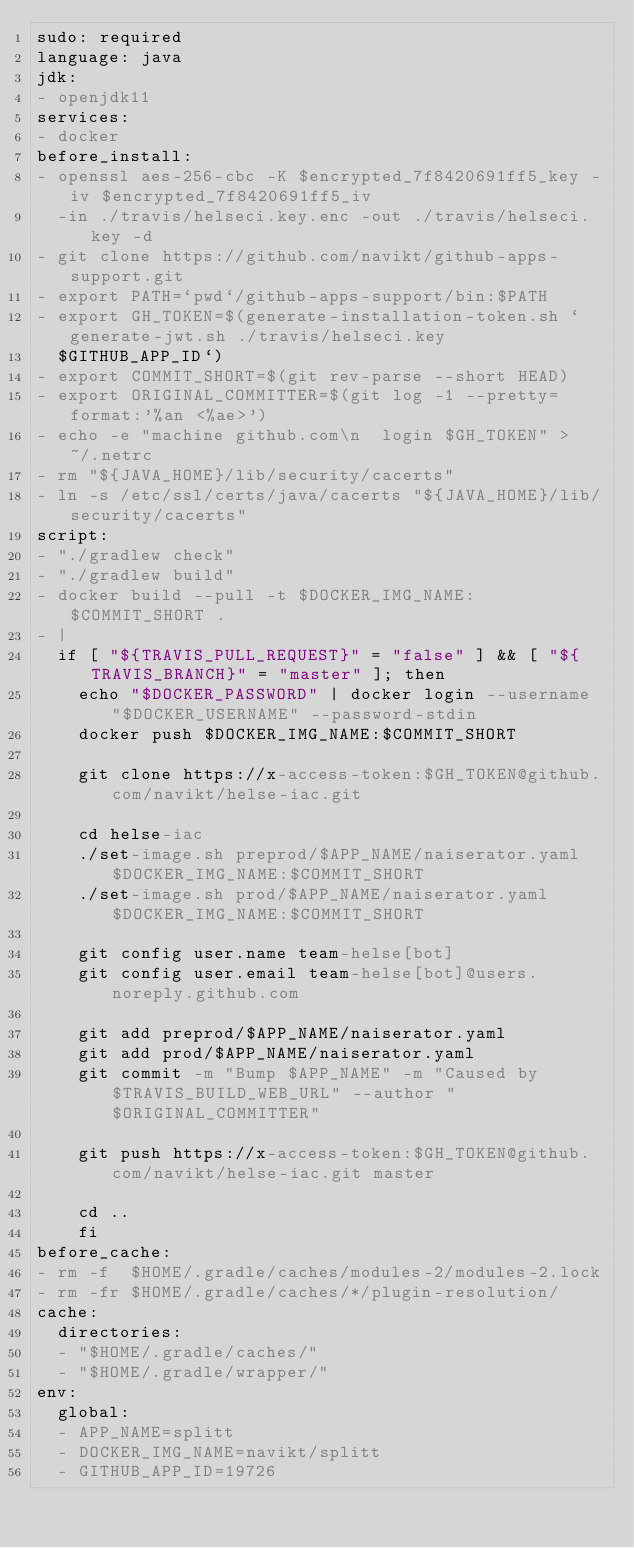<code> <loc_0><loc_0><loc_500><loc_500><_YAML_>sudo: required
language: java
jdk:
- openjdk11
services:
- docker
before_install:
- openssl aes-256-cbc -K $encrypted_7f8420691ff5_key -iv $encrypted_7f8420691ff5_iv
  -in ./travis/helseci.key.enc -out ./travis/helseci.key -d
- git clone https://github.com/navikt/github-apps-support.git
- export PATH=`pwd`/github-apps-support/bin:$PATH
- export GH_TOKEN=$(generate-installation-token.sh `generate-jwt.sh ./travis/helseci.key
  $GITHUB_APP_ID`)
- export COMMIT_SHORT=$(git rev-parse --short HEAD)
- export ORIGINAL_COMMITTER=$(git log -1 --pretty=format:'%an <%ae>')
- echo -e "machine github.com\n  login $GH_TOKEN" > ~/.netrc
- rm "${JAVA_HOME}/lib/security/cacerts"
- ln -s /etc/ssl/certs/java/cacerts "${JAVA_HOME}/lib/security/cacerts"
script:
- "./gradlew check"
- "./gradlew build"
- docker build --pull -t $DOCKER_IMG_NAME:$COMMIT_SHORT .
- |
  if [ "${TRAVIS_PULL_REQUEST}" = "false" ] && [ "${TRAVIS_BRANCH}" = "master" ]; then
    echo "$DOCKER_PASSWORD" | docker login --username "$DOCKER_USERNAME" --password-stdin
    docker push $DOCKER_IMG_NAME:$COMMIT_SHORT

    git clone https://x-access-token:$GH_TOKEN@github.com/navikt/helse-iac.git

    cd helse-iac
    ./set-image.sh preprod/$APP_NAME/naiserator.yaml $DOCKER_IMG_NAME:$COMMIT_SHORT
    ./set-image.sh prod/$APP_NAME/naiserator.yaml $DOCKER_IMG_NAME:$COMMIT_SHORT

    git config user.name team-helse[bot]
    git config user.email team-helse[bot]@users.noreply.github.com

    git add preprod/$APP_NAME/naiserator.yaml
    git add prod/$APP_NAME/naiserator.yaml
    git commit -m "Bump $APP_NAME" -m "Caused by $TRAVIS_BUILD_WEB_URL" --author "$ORIGINAL_COMMITTER"

    git push https://x-access-token:$GH_TOKEN@github.com/navikt/helse-iac.git master

    cd ..
    fi
before_cache:
- rm -f  $HOME/.gradle/caches/modules-2/modules-2.lock
- rm -fr $HOME/.gradle/caches/*/plugin-resolution/
cache:
  directories:
  - "$HOME/.gradle/caches/"
  - "$HOME/.gradle/wrapper/"
env:
  global:
  - APP_NAME=splitt
  - DOCKER_IMG_NAME=navikt/splitt
  - GITHUB_APP_ID=19726</code> 